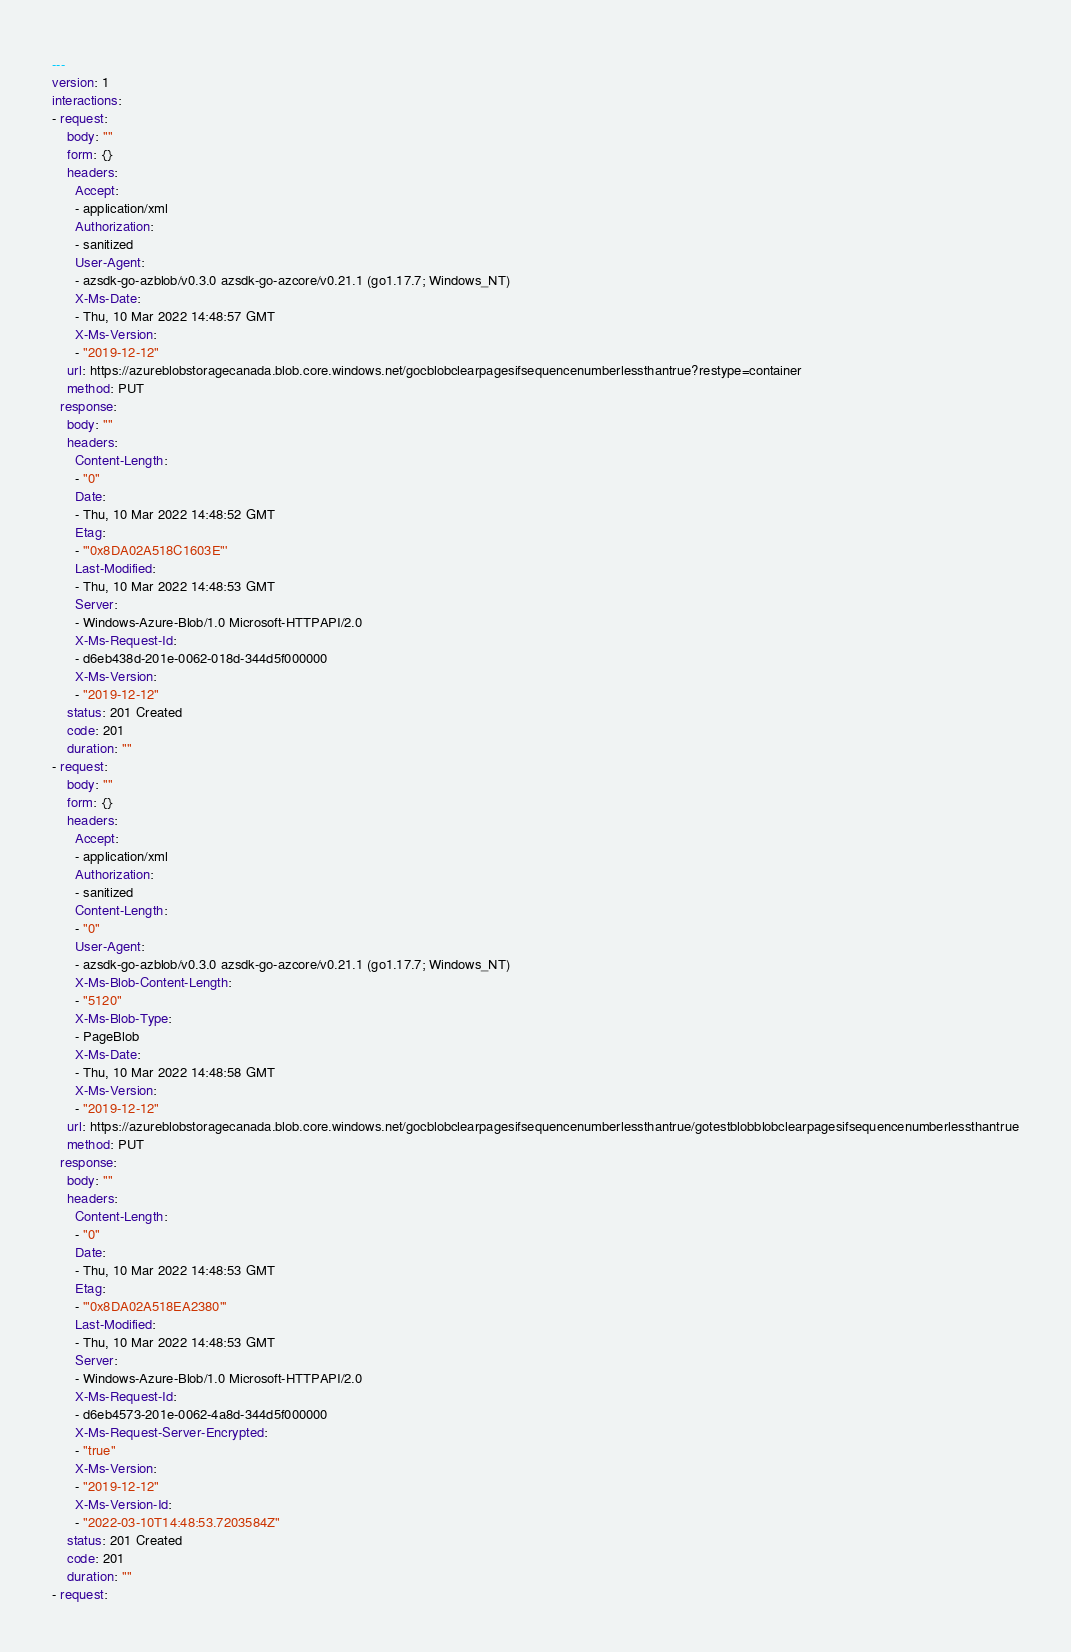Convert code to text. <code><loc_0><loc_0><loc_500><loc_500><_YAML_>---
version: 1
interactions:
- request:
    body: ""
    form: {}
    headers:
      Accept:
      - application/xml
      Authorization:
      - sanitized
      User-Agent:
      - azsdk-go-azblob/v0.3.0 azsdk-go-azcore/v0.21.1 (go1.17.7; Windows_NT)
      X-Ms-Date:
      - Thu, 10 Mar 2022 14:48:57 GMT
      X-Ms-Version:
      - "2019-12-12"
    url: https://azureblobstoragecanada.blob.core.windows.net/gocblobclearpagesifsequencenumberlessthantrue?restype=container
    method: PUT
  response:
    body: ""
    headers:
      Content-Length:
      - "0"
      Date:
      - Thu, 10 Mar 2022 14:48:52 GMT
      Etag:
      - '"0x8DA02A518C1603E"'
      Last-Modified:
      - Thu, 10 Mar 2022 14:48:53 GMT
      Server:
      - Windows-Azure-Blob/1.0 Microsoft-HTTPAPI/2.0
      X-Ms-Request-Id:
      - d6eb438d-201e-0062-018d-344d5f000000
      X-Ms-Version:
      - "2019-12-12"
    status: 201 Created
    code: 201
    duration: ""
- request:
    body: ""
    form: {}
    headers:
      Accept:
      - application/xml
      Authorization:
      - sanitized
      Content-Length:
      - "0"
      User-Agent:
      - azsdk-go-azblob/v0.3.0 azsdk-go-azcore/v0.21.1 (go1.17.7; Windows_NT)
      X-Ms-Blob-Content-Length:
      - "5120"
      X-Ms-Blob-Type:
      - PageBlob
      X-Ms-Date:
      - Thu, 10 Mar 2022 14:48:58 GMT
      X-Ms-Version:
      - "2019-12-12"
    url: https://azureblobstoragecanada.blob.core.windows.net/gocblobclearpagesifsequencenumberlessthantrue/gotestblobblobclearpagesifsequencenumberlessthantrue
    method: PUT
  response:
    body: ""
    headers:
      Content-Length:
      - "0"
      Date:
      - Thu, 10 Mar 2022 14:48:53 GMT
      Etag:
      - '"0x8DA02A518EA2380"'
      Last-Modified:
      - Thu, 10 Mar 2022 14:48:53 GMT
      Server:
      - Windows-Azure-Blob/1.0 Microsoft-HTTPAPI/2.0
      X-Ms-Request-Id:
      - d6eb4573-201e-0062-4a8d-344d5f000000
      X-Ms-Request-Server-Encrypted:
      - "true"
      X-Ms-Version:
      - "2019-12-12"
      X-Ms-Version-Id:
      - "2022-03-10T14:48:53.7203584Z"
    status: 201 Created
    code: 201
    duration: ""
- request:</code> 